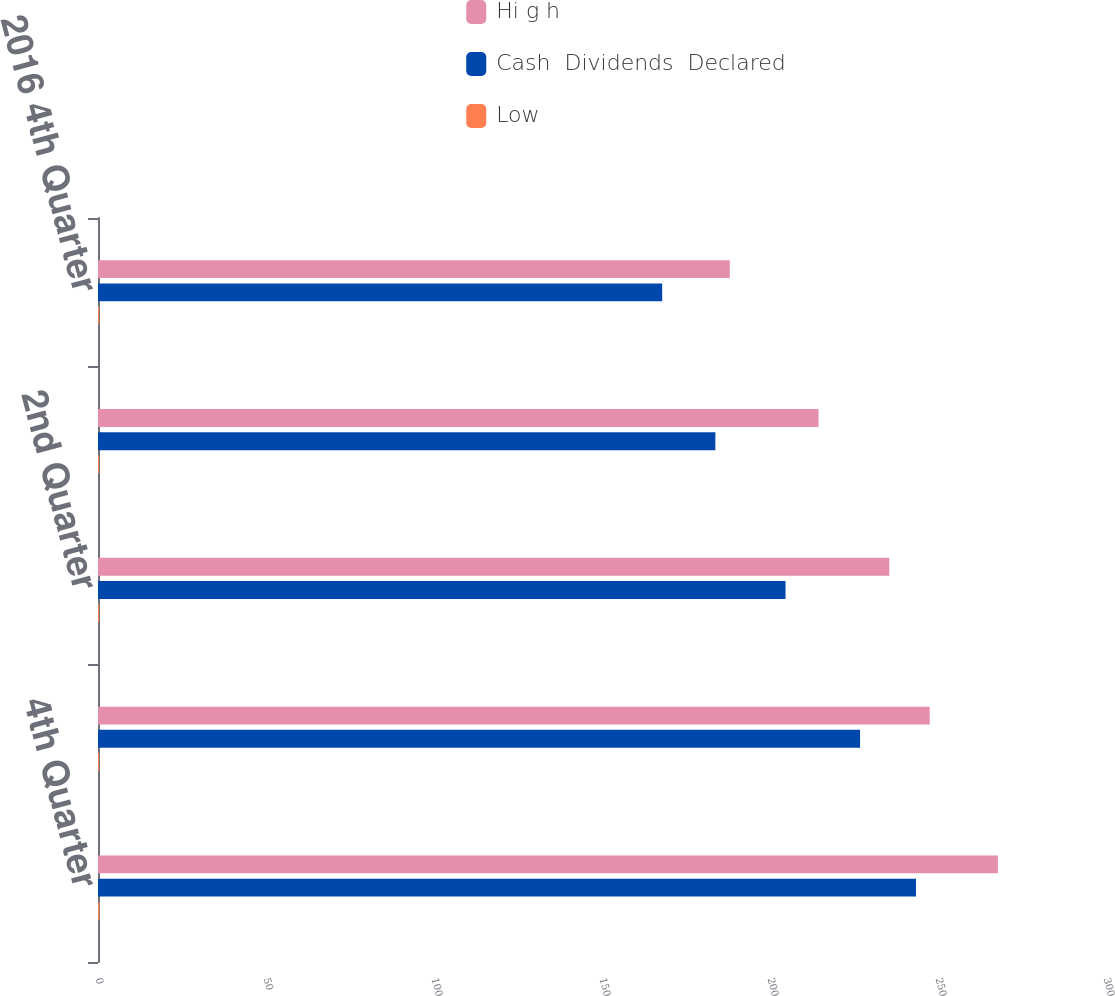Convert chart. <chart><loc_0><loc_0><loc_500><loc_500><stacked_bar_chart><ecel><fcel>4th Quarter<fcel>3rd Quarter<fcel>2nd Quarter<fcel>1st Quarter<fcel>2016 4th Quarter<nl><fcel>Hi g h<fcel>267.83<fcel>247.54<fcel>235.5<fcel>214.44<fcel>188.04<nl><fcel>Cash  Dividends  Declared<fcel>243.45<fcel>226.81<fcel>204.62<fcel>183.74<fcel>167.91<nl><fcel>Low<fcel>0.41<fcel>0.35<fcel>0.35<fcel>0.35<fcel>0.35<nl></chart> 